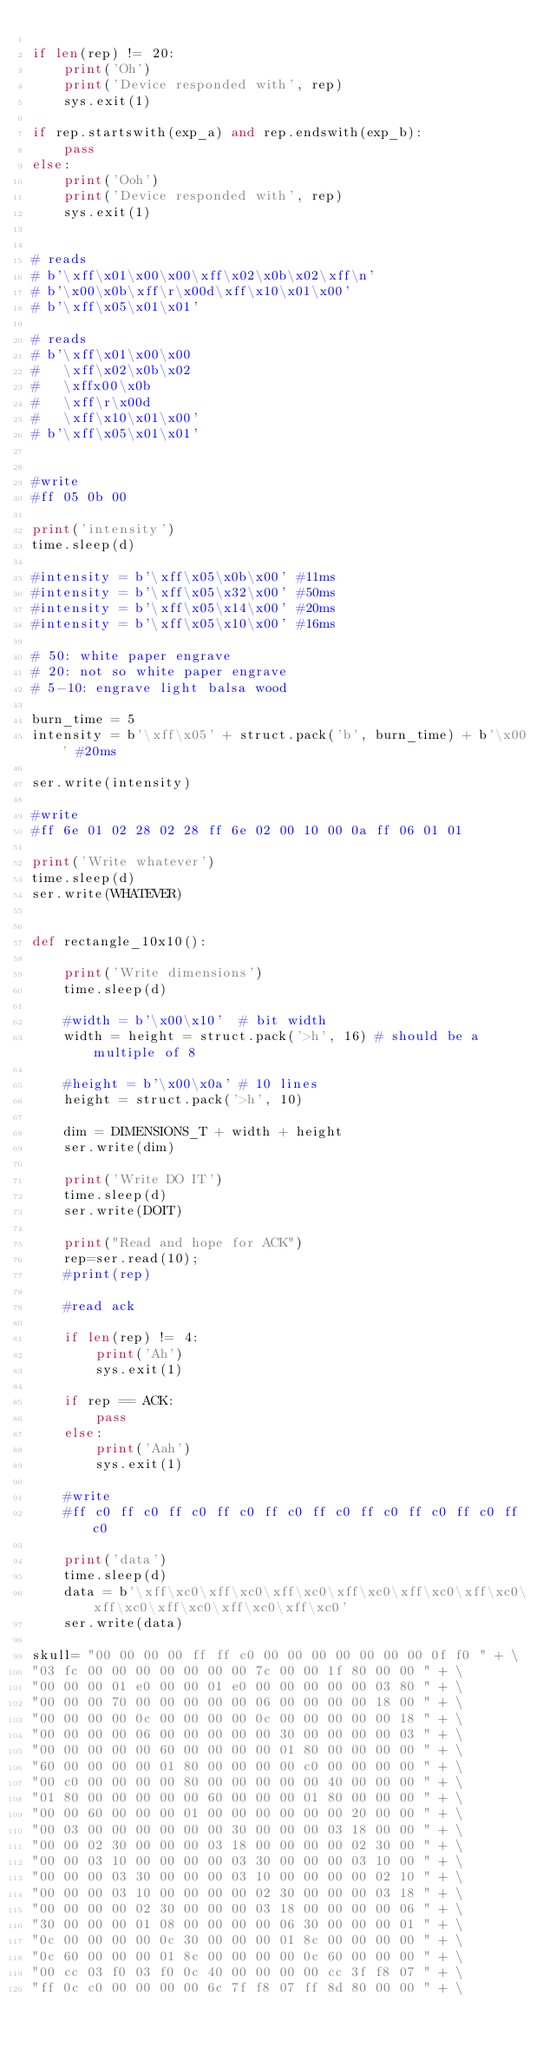<code> <loc_0><loc_0><loc_500><loc_500><_Python_>
if len(rep) != 20:
    print('Oh')
    print('Device responded with', rep)
    sys.exit(1)

if rep.startswith(exp_a) and rep.endswith(exp_b):
    pass
else:
    print('Ooh')
    print('Device responded with', rep)
    sys.exit(1)


# reads
# b'\xff\x01\x00\x00\xff\x02\x0b\x02\xff\n'
# b'\x00\x0b\xff\r\x00d\xff\x10\x01\x00'
# b'\xff\x05\x01\x01'

# reads
# b'\xff\x01\x00\x00
#   \xff\x02\x0b\x02
#   \xffx00\x0b
#   \xff\r\x00d
#   \xff\x10\x01\x00'
# b'\xff\x05\x01\x01'


#write
#ff 05 0b 00

print('intensity')
time.sleep(d)

#intensity = b'\xff\x05\x0b\x00' #11ms
#intensity = b'\xff\x05\x32\x00' #50ms
#intensity = b'\xff\x05\x14\x00' #20ms
#intensity = b'\xff\x05\x10\x00' #16ms

# 50: white paper engrave
# 20: not so white paper engrave
# 5-10: engrave light balsa wood

burn_time = 5
intensity = b'\xff\x05' + struct.pack('b', burn_time) + b'\x00' #20ms

ser.write(intensity)

#write
#ff 6e 01 02 28 02 28 ff 6e 02 00 10 00 0a ff 06 01 01

print('Write whatever')
time.sleep(d)
ser.write(WHATEVER)


def rectangle_10x10():

    print('Write dimensions')
    time.sleep(d)

    #width = b'\x00\x10'  # bit width
    width = height = struct.pack('>h', 16) # should be a multiple of 8

    #height = b'\x00\x0a' # 10 lines
    height = struct.pack('>h', 10)

    dim = DIMENSIONS_T + width + height
    ser.write(dim)

    print('Write DO IT')
    time.sleep(d)
    ser.write(DOIT)

    print("Read and hope for ACK")
    rep=ser.read(10);
    #print(rep)

    #read ack

    if len(rep) != 4:
        print('Ah')
        sys.exit(1)

    if rep == ACK:
        pass
    else:
        print('Aah')
        sys.exit(1)

    #write
    #ff c0 ff c0 ff c0 ff c0 ff c0 ff c0 ff c0 ff c0 ff c0 ff c0

    print('data')
    time.sleep(d)
    data = b'\xff\xc0\xff\xc0\xff\xc0\xff\xc0\xff\xc0\xff\xc0\xff\xc0\xff\xc0\xff\xc0\xff\xc0'
    ser.write(data)

skull= "00 00 00 00 ff ff c0 00 00 00 00 00 00 00 0f f0 " + \
"03 fc 00 00 00 00 00 00 00 7c 00 00 1f 80 00 00 " + \
"00 00 00 01 e0 00 00 01 e0 00 00 00 00 00 03 80 " + \
"00 00 00 70 00 00 00 00 00 06 00 00 00 00 18 00 " + \
"00 00 00 00 0c 00 00 00 00 0c 00 00 00 00 00 18 " + \
"00 00 00 00 06 00 00 00 00 00 30 00 00 00 00 03 " + \
"00 00 00 00 00 60 00 00 00 00 01 80 00 00 00 00 " + \
"60 00 00 00 00 01 80 00 00 00 00 c0 00 00 00 00 " + \
"00 c0 00 00 00 00 80 00 00 00 00 00 40 00 00 00 " + \
"01 80 00 00 00 00 00 60 00 00 00 01 80 00 00 00 " + \
"00 00 60 00 00 00 01 00 00 00 00 00 00 20 00 00 " + \
"00 03 00 00 00 00 00 00 30 00 00 00 03 18 00 00 " + \
"00 00 02 30 00 00 00 03 18 00 00 00 00 02 30 00 " + \
"00 00 03 10 00 00 00 00 03 30 00 00 00 03 10 00 " + \
"00 00 00 03 30 00 00 00 03 10 00 00 00 00 02 10 " + \
"00 00 00 03 10 00 00 00 00 02 30 00 00 00 03 18 " + \
"00 00 00 00 02 30 00 00 00 03 18 00 00 00 00 06 " + \
"30 00 00 00 01 08 00 00 00 00 06 30 00 00 00 01 " + \
"0c 00 00 00 00 0c 30 00 00 00 01 8c 00 00 00 00 " + \
"0c 60 00 00 00 01 8c 00 00 00 00 0c 60 00 00 00 " + \
"00 cc 03 f0 03 f0 0c 40 00 00 00 00 cc 3f f8 07 " + \
"ff 0c c0 00 00 00 00 6c 7f f8 07 ff 8d 80 00 00 " + \</code> 